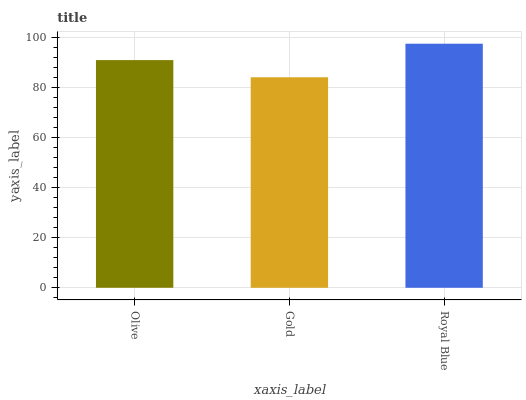Is Royal Blue the minimum?
Answer yes or no. No. Is Gold the maximum?
Answer yes or no. No. Is Royal Blue greater than Gold?
Answer yes or no. Yes. Is Gold less than Royal Blue?
Answer yes or no. Yes. Is Gold greater than Royal Blue?
Answer yes or no. No. Is Royal Blue less than Gold?
Answer yes or no. No. Is Olive the high median?
Answer yes or no. Yes. Is Olive the low median?
Answer yes or no. Yes. Is Gold the high median?
Answer yes or no. No. Is Gold the low median?
Answer yes or no. No. 